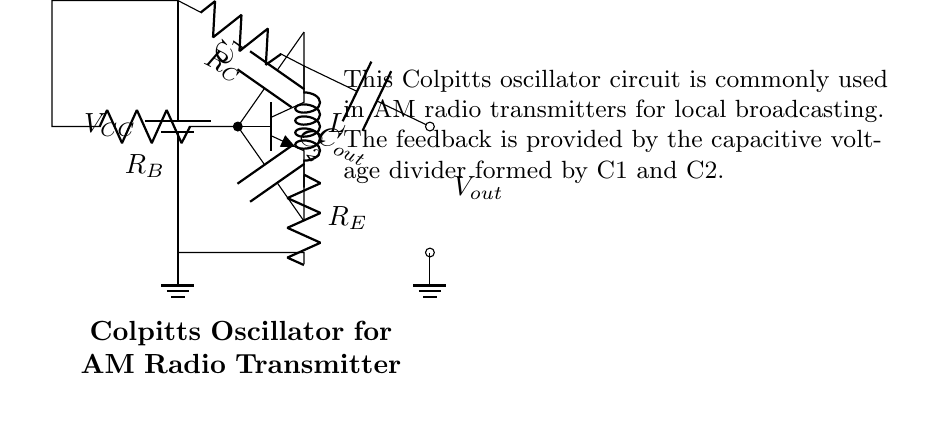What type of transistor is used in this circuit? The circuit uses an NPN transistor, which is indicated by the label on the transistor symbol in the diagram.
Answer: NPN What is the role of C1 and C2 in the oscillator? C1 and C2 form a capacitive voltage divider, which is a key feature that provides feedback for the oscillation process in the Colpitts oscillator.
Answer: Feedback What is the output voltage (Vout) taken from? The output voltage is taken from the point after the capacitor labeled Cout, which is connected to the collector of the transistor.
Answer: Collector What are the resistances connected to the base, collector, and emitter? The resistances are labeled as R_B for the base, R_C for the collector, and R_E for the emitter in the circuit diagram.
Answer: R_B, R_C, R_E What component determines the frequency of oscillation? The frequency of oscillation is determined by the combination of the capacitors C1, C2, and the inductor L in the feedback loop.
Answer: C1, C2, and L Why is the ground connection important in this circuit? The ground connection provides a common reference point for the circuit, stabilizing the voltage levels and ensuring proper operation of the amplifier stage.
Answer: Reference point How does the circuit achieve oscillation? The circuit achieves oscillation through positive feedback provided by the voltage divider formed by the capacitors and the inductive component, creating a resonant condition.
Answer: Resonance 